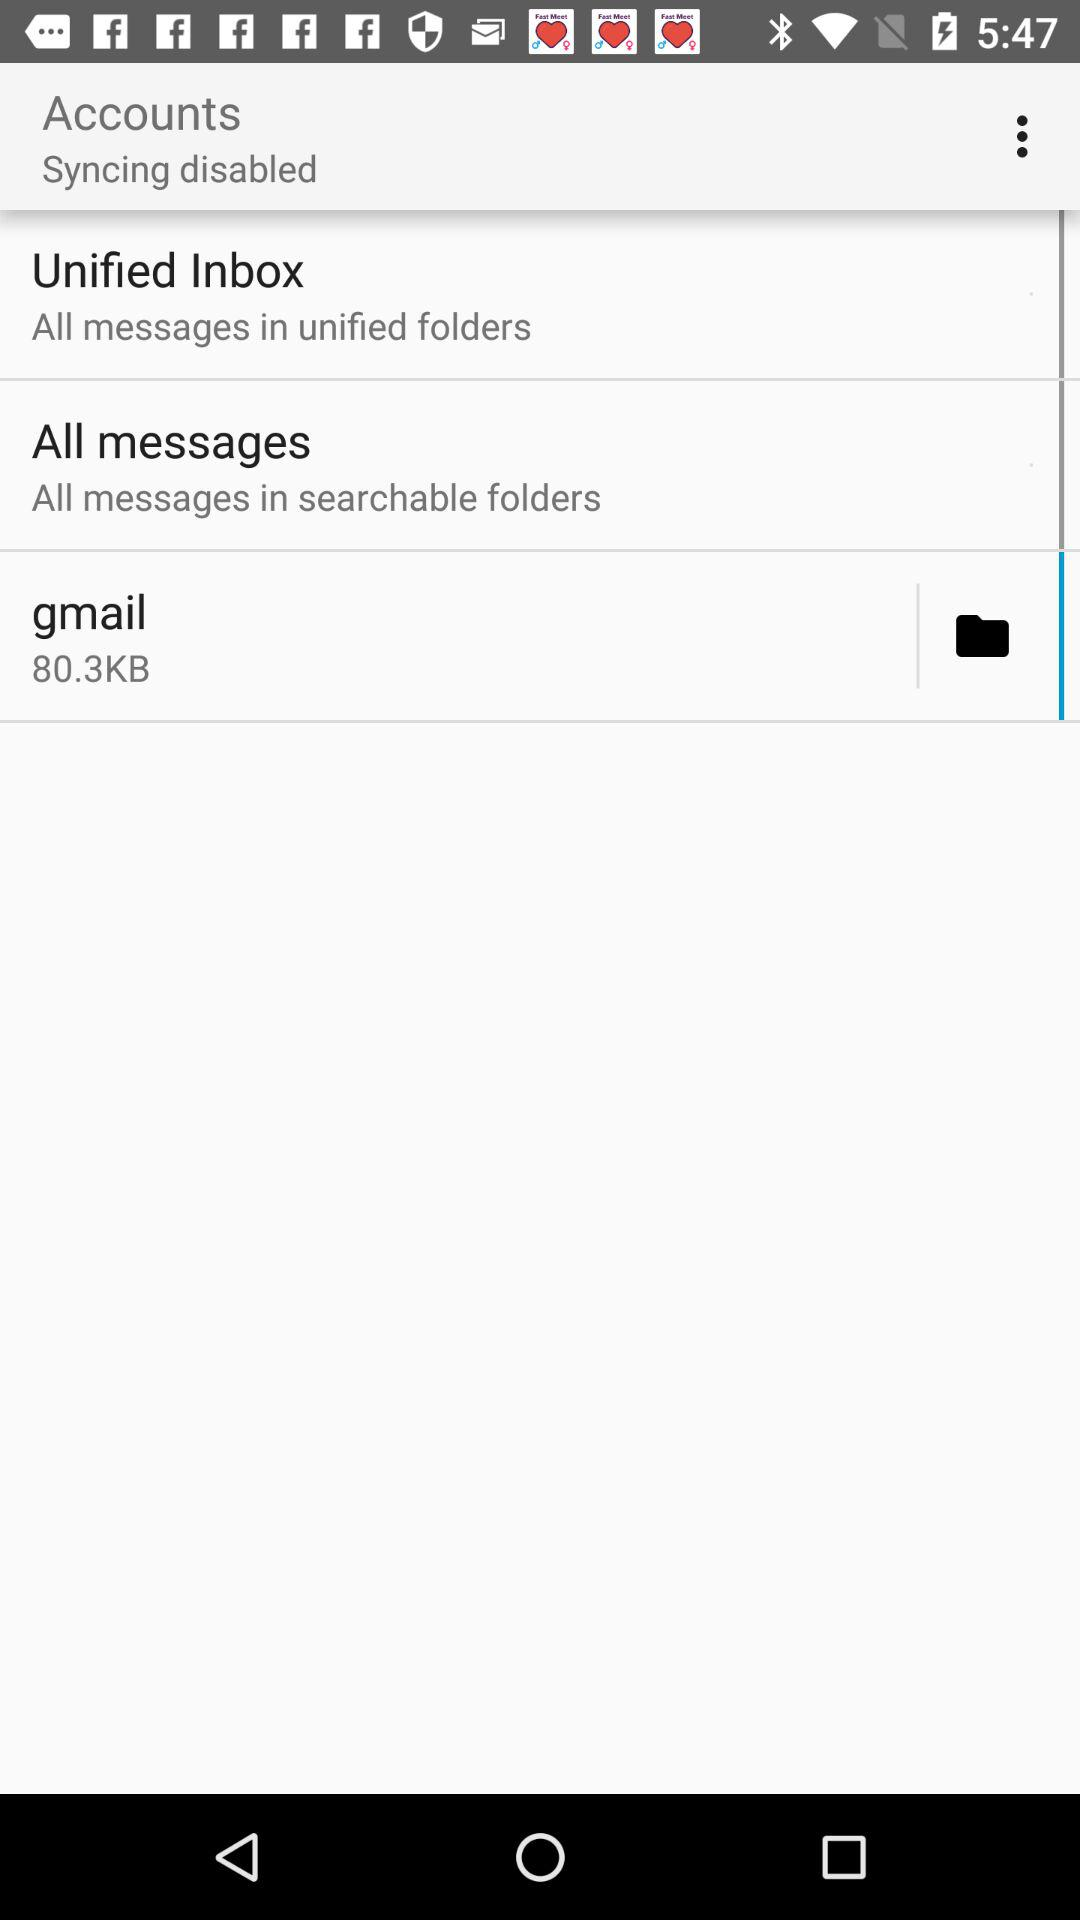What is the size of the Gmail file? The size of the Gmail file is 80.3 KB. 